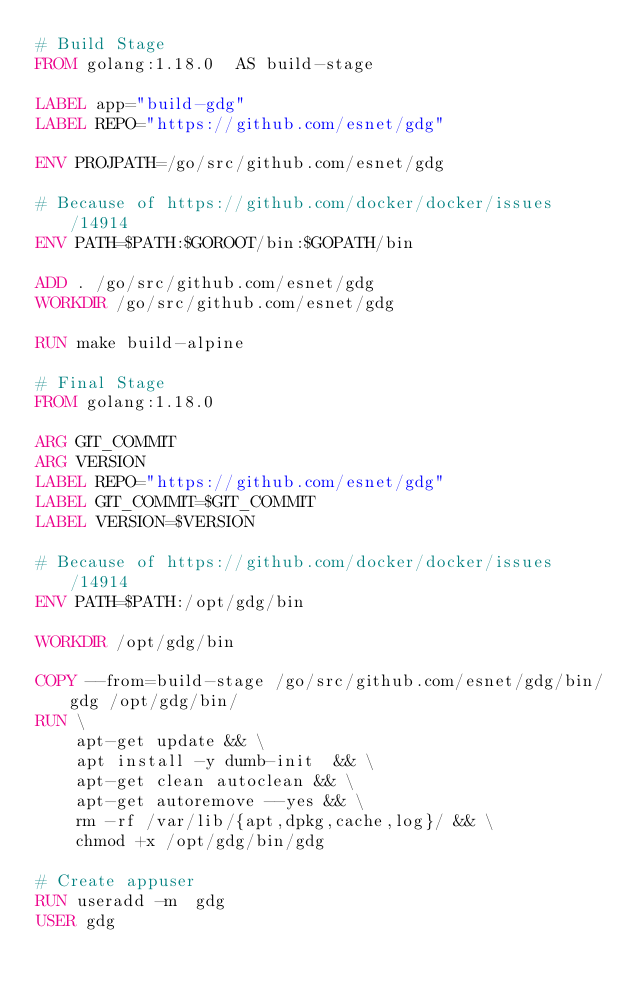Convert code to text. <code><loc_0><loc_0><loc_500><loc_500><_Dockerfile_># Build Stage
FROM golang:1.18.0  AS build-stage

LABEL app="build-gdg"
LABEL REPO="https://github.com/esnet/gdg"

ENV PROJPATH=/go/src/github.com/esnet/gdg

# Because of https://github.com/docker/docker/issues/14914
ENV PATH=$PATH:$GOROOT/bin:$GOPATH/bin

ADD . /go/src/github.com/esnet/gdg
WORKDIR /go/src/github.com/esnet/gdg

RUN make build-alpine

# Final Stage
FROM golang:1.18.0 

ARG GIT_COMMIT
ARG VERSION
LABEL REPO="https://github.com/esnet/gdg"
LABEL GIT_COMMIT=$GIT_COMMIT
LABEL VERSION=$VERSION

# Because of https://github.com/docker/docker/issues/14914
ENV PATH=$PATH:/opt/gdg/bin

WORKDIR /opt/gdg/bin

COPY --from=build-stage /go/src/github.com/esnet/gdg/bin/gdg /opt/gdg/bin/
RUN \
    apt-get update && \
    apt install -y dumb-init  && \
    apt-get clean autoclean && \
    apt-get autoremove --yes && \
    rm -rf /var/lib/{apt,dpkg,cache,log}/ && \
    chmod +x /opt/gdg/bin/gdg

# Create appuser
RUN useradd -m  gdg
USER gdg
</code> 